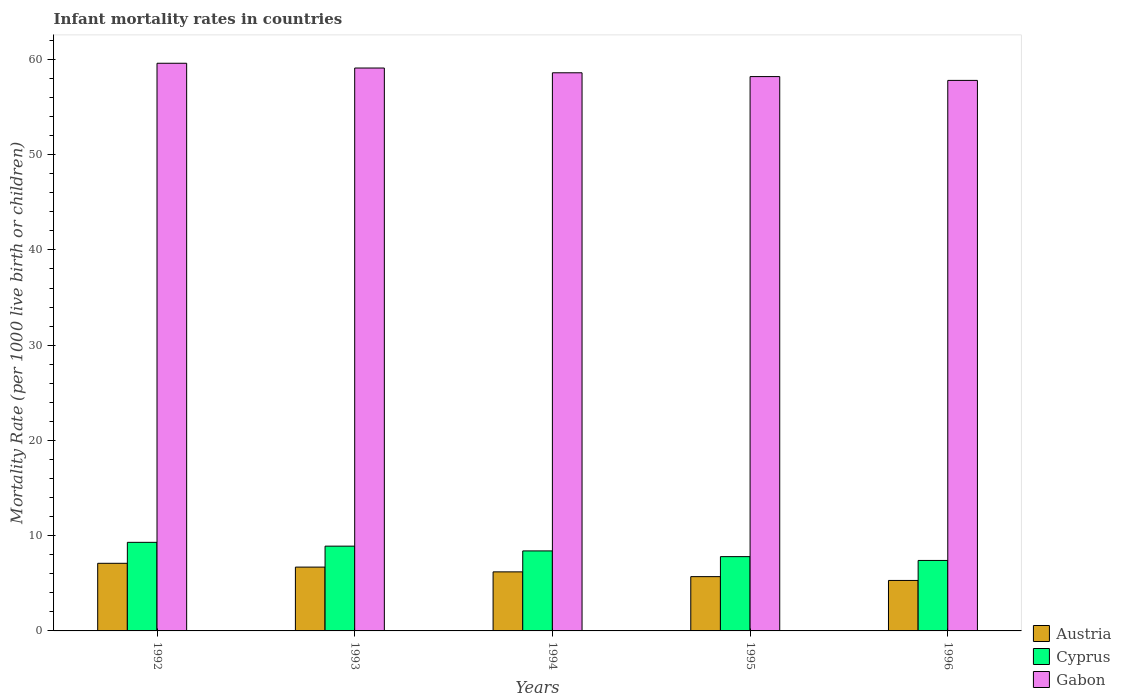How many different coloured bars are there?
Your answer should be very brief. 3. How many groups of bars are there?
Provide a succinct answer. 5. Are the number of bars per tick equal to the number of legend labels?
Give a very brief answer. Yes. Are the number of bars on each tick of the X-axis equal?
Ensure brevity in your answer.  Yes. How many bars are there on the 5th tick from the right?
Make the answer very short. 3. In how many cases, is the number of bars for a given year not equal to the number of legend labels?
Keep it short and to the point. 0. In which year was the infant mortality rate in Cyprus maximum?
Your answer should be very brief. 1992. In which year was the infant mortality rate in Cyprus minimum?
Provide a succinct answer. 1996. What is the total infant mortality rate in Gabon in the graph?
Keep it short and to the point. 293.3. What is the difference between the infant mortality rate in Cyprus in 1992 and that in 1995?
Make the answer very short. 1.5. What is the difference between the infant mortality rate in Cyprus in 1996 and the infant mortality rate in Austria in 1995?
Your answer should be very brief. 1.7. In the year 1992, what is the difference between the infant mortality rate in Gabon and infant mortality rate in Cyprus?
Keep it short and to the point. 50.3. What is the ratio of the infant mortality rate in Cyprus in 1993 to that in 1996?
Ensure brevity in your answer.  1.2. What is the difference between the highest and the second highest infant mortality rate in Cyprus?
Keep it short and to the point. 0.4. What is the difference between the highest and the lowest infant mortality rate in Cyprus?
Provide a succinct answer. 1.9. In how many years, is the infant mortality rate in Gabon greater than the average infant mortality rate in Gabon taken over all years?
Your answer should be compact. 2. What does the 3rd bar from the left in 1994 represents?
Make the answer very short. Gabon. How many bars are there?
Your response must be concise. 15. Are all the bars in the graph horizontal?
Your answer should be compact. No. What is the difference between two consecutive major ticks on the Y-axis?
Offer a very short reply. 10. How many legend labels are there?
Give a very brief answer. 3. What is the title of the graph?
Provide a short and direct response. Infant mortality rates in countries. What is the label or title of the Y-axis?
Offer a very short reply. Mortality Rate (per 1000 live birth or children). What is the Mortality Rate (per 1000 live birth or children) in Austria in 1992?
Provide a short and direct response. 7.1. What is the Mortality Rate (per 1000 live birth or children) of Gabon in 1992?
Provide a succinct answer. 59.6. What is the Mortality Rate (per 1000 live birth or children) in Austria in 1993?
Provide a succinct answer. 6.7. What is the Mortality Rate (per 1000 live birth or children) in Gabon in 1993?
Make the answer very short. 59.1. What is the Mortality Rate (per 1000 live birth or children) of Austria in 1994?
Make the answer very short. 6.2. What is the Mortality Rate (per 1000 live birth or children) of Cyprus in 1994?
Make the answer very short. 8.4. What is the Mortality Rate (per 1000 live birth or children) in Gabon in 1994?
Provide a succinct answer. 58.6. What is the Mortality Rate (per 1000 live birth or children) in Austria in 1995?
Offer a very short reply. 5.7. What is the Mortality Rate (per 1000 live birth or children) in Cyprus in 1995?
Your answer should be very brief. 7.8. What is the Mortality Rate (per 1000 live birth or children) in Gabon in 1995?
Make the answer very short. 58.2. What is the Mortality Rate (per 1000 live birth or children) of Cyprus in 1996?
Offer a terse response. 7.4. What is the Mortality Rate (per 1000 live birth or children) in Gabon in 1996?
Provide a succinct answer. 57.8. Across all years, what is the maximum Mortality Rate (per 1000 live birth or children) of Austria?
Give a very brief answer. 7.1. Across all years, what is the maximum Mortality Rate (per 1000 live birth or children) in Gabon?
Provide a succinct answer. 59.6. Across all years, what is the minimum Mortality Rate (per 1000 live birth or children) in Cyprus?
Provide a short and direct response. 7.4. Across all years, what is the minimum Mortality Rate (per 1000 live birth or children) in Gabon?
Provide a short and direct response. 57.8. What is the total Mortality Rate (per 1000 live birth or children) of Austria in the graph?
Ensure brevity in your answer.  31. What is the total Mortality Rate (per 1000 live birth or children) of Cyprus in the graph?
Your answer should be very brief. 41.8. What is the total Mortality Rate (per 1000 live birth or children) of Gabon in the graph?
Make the answer very short. 293.3. What is the difference between the Mortality Rate (per 1000 live birth or children) in Austria in 1992 and that in 1994?
Offer a very short reply. 0.9. What is the difference between the Mortality Rate (per 1000 live birth or children) of Cyprus in 1992 and that in 1995?
Make the answer very short. 1.5. What is the difference between the Mortality Rate (per 1000 live birth or children) in Gabon in 1992 and that in 1995?
Offer a terse response. 1.4. What is the difference between the Mortality Rate (per 1000 live birth or children) in Austria in 1992 and that in 1996?
Offer a terse response. 1.8. What is the difference between the Mortality Rate (per 1000 live birth or children) of Cyprus in 1992 and that in 1996?
Ensure brevity in your answer.  1.9. What is the difference between the Mortality Rate (per 1000 live birth or children) of Austria in 1993 and that in 1994?
Provide a short and direct response. 0.5. What is the difference between the Mortality Rate (per 1000 live birth or children) in Cyprus in 1993 and that in 1994?
Ensure brevity in your answer.  0.5. What is the difference between the Mortality Rate (per 1000 live birth or children) of Gabon in 1993 and that in 1995?
Your answer should be very brief. 0.9. What is the difference between the Mortality Rate (per 1000 live birth or children) in Austria in 1993 and that in 1996?
Provide a short and direct response. 1.4. What is the difference between the Mortality Rate (per 1000 live birth or children) in Gabon in 1993 and that in 1996?
Offer a very short reply. 1.3. What is the difference between the Mortality Rate (per 1000 live birth or children) in Austria in 1994 and that in 1995?
Your response must be concise. 0.5. What is the difference between the Mortality Rate (per 1000 live birth or children) in Cyprus in 1994 and that in 1996?
Provide a short and direct response. 1. What is the difference between the Mortality Rate (per 1000 live birth or children) in Gabon in 1994 and that in 1996?
Your response must be concise. 0.8. What is the difference between the Mortality Rate (per 1000 live birth or children) in Austria in 1995 and that in 1996?
Keep it short and to the point. 0.4. What is the difference between the Mortality Rate (per 1000 live birth or children) in Cyprus in 1995 and that in 1996?
Your answer should be very brief. 0.4. What is the difference between the Mortality Rate (per 1000 live birth or children) in Austria in 1992 and the Mortality Rate (per 1000 live birth or children) in Gabon in 1993?
Provide a short and direct response. -52. What is the difference between the Mortality Rate (per 1000 live birth or children) of Cyprus in 1992 and the Mortality Rate (per 1000 live birth or children) of Gabon in 1993?
Give a very brief answer. -49.8. What is the difference between the Mortality Rate (per 1000 live birth or children) of Austria in 1992 and the Mortality Rate (per 1000 live birth or children) of Gabon in 1994?
Offer a very short reply. -51.5. What is the difference between the Mortality Rate (per 1000 live birth or children) of Cyprus in 1992 and the Mortality Rate (per 1000 live birth or children) of Gabon in 1994?
Make the answer very short. -49.3. What is the difference between the Mortality Rate (per 1000 live birth or children) in Austria in 1992 and the Mortality Rate (per 1000 live birth or children) in Gabon in 1995?
Your response must be concise. -51.1. What is the difference between the Mortality Rate (per 1000 live birth or children) in Cyprus in 1992 and the Mortality Rate (per 1000 live birth or children) in Gabon in 1995?
Give a very brief answer. -48.9. What is the difference between the Mortality Rate (per 1000 live birth or children) of Austria in 1992 and the Mortality Rate (per 1000 live birth or children) of Cyprus in 1996?
Offer a terse response. -0.3. What is the difference between the Mortality Rate (per 1000 live birth or children) in Austria in 1992 and the Mortality Rate (per 1000 live birth or children) in Gabon in 1996?
Ensure brevity in your answer.  -50.7. What is the difference between the Mortality Rate (per 1000 live birth or children) in Cyprus in 1992 and the Mortality Rate (per 1000 live birth or children) in Gabon in 1996?
Your response must be concise. -48.5. What is the difference between the Mortality Rate (per 1000 live birth or children) in Austria in 1993 and the Mortality Rate (per 1000 live birth or children) in Gabon in 1994?
Your response must be concise. -51.9. What is the difference between the Mortality Rate (per 1000 live birth or children) of Cyprus in 1993 and the Mortality Rate (per 1000 live birth or children) of Gabon in 1994?
Ensure brevity in your answer.  -49.7. What is the difference between the Mortality Rate (per 1000 live birth or children) in Austria in 1993 and the Mortality Rate (per 1000 live birth or children) in Cyprus in 1995?
Your answer should be very brief. -1.1. What is the difference between the Mortality Rate (per 1000 live birth or children) of Austria in 1993 and the Mortality Rate (per 1000 live birth or children) of Gabon in 1995?
Keep it short and to the point. -51.5. What is the difference between the Mortality Rate (per 1000 live birth or children) of Cyprus in 1993 and the Mortality Rate (per 1000 live birth or children) of Gabon in 1995?
Provide a succinct answer. -49.3. What is the difference between the Mortality Rate (per 1000 live birth or children) in Austria in 1993 and the Mortality Rate (per 1000 live birth or children) in Cyprus in 1996?
Keep it short and to the point. -0.7. What is the difference between the Mortality Rate (per 1000 live birth or children) of Austria in 1993 and the Mortality Rate (per 1000 live birth or children) of Gabon in 1996?
Your response must be concise. -51.1. What is the difference between the Mortality Rate (per 1000 live birth or children) of Cyprus in 1993 and the Mortality Rate (per 1000 live birth or children) of Gabon in 1996?
Provide a succinct answer. -48.9. What is the difference between the Mortality Rate (per 1000 live birth or children) of Austria in 1994 and the Mortality Rate (per 1000 live birth or children) of Cyprus in 1995?
Your answer should be very brief. -1.6. What is the difference between the Mortality Rate (per 1000 live birth or children) of Austria in 1994 and the Mortality Rate (per 1000 live birth or children) of Gabon in 1995?
Offer a terse response. -52. What is the difference between the Mortality Rate (per 1000 live birth or children) in Cyprus in 1994 and the Mortality Rate (per 1000 live birth or children) in Gabon in 1995?
Make the answer very short. -49.8. What is the difference between the Mortality Rate (per 1000 live birth or children) of Austria in 1994 and the Mortality Rate (per 1000 live birth or children) of Gabon in 1996?
Keep it short and to the point. -51.6. What is the difference between the Mortality Rate (per 1000 live birth or children) in Cyprus in 1994 and the Mortality Rate (per 1000 live birth or children) in Gabon in 1996?
Your answer should be compact. -49.4. What is the difference between the Mortality Rate (per 1000 live birth or children) in Austria in 1995 and the Mortality Rate (per 1000 live birth or children) in Cyprus in 1996?
Your answer should be very brief. -1.7. What is the difference between the Mortality Rate (per 1000 live birth or children) in Austria in 1995 and the Mortality Rate (per 1000 live birth or children) in Gabon in 1996?
Give a very brief answer. -52.1. What is the average Mortality Rate (per 1000 live birth or children) of Austria per year?
Provide a short and direct response. 6.2. What is the average Mortality Rate (per 1000 live birth or children) of Cyprus per year?
Offer a terse response. 8.36. What is the average Mortality Rate (per 1000 live birth or children) in Gabon per year?
Your response must be concise. 58.66. In the year 1992, what is the difference between the Mortality Rate (per 1000 live birth or children) in Austria and Mortality Rate (per 1000 live birth or children) in Cyprus?
Offer a very short reply. -2.2. In the year 1992, what is the difference between the Mortality Rate (per 1000 live birth or children) of Austria and Mortality Rate (per 1000 live birth or children) of Gabon?
Your response must be concise. -52.5. In the year 1992, what is the difference between the Mortality Rate (per 1000 live birth or children) in Cyprus and Mortality Rate (per 1000 live birth or children) in Gabon?
Ensure brevity in your answer.  -50.3. In the year 1993, what is the difference between the Mortality Rate (per 1000 live birth or children) of Austria and Mortality Rate (per 1000 live birth or children) of Cyprus?
Provide a short and direct response. -2.2. In the year 1993, what is the difference between the Mortality Rate (per 1000 live birth or children) of Austria and Mortality Rate (per 1000 live birth or children) of Gabon?
Offer a terse response. -52.4. In the year 1993, what is the difference between the Mortality Rate (per 1000 live birth or children) in Cyprus and Mortality Rate (per 1000 live birth or children) in Gabon?
Offer a terse response. -50.2. In the year 1994, what is the difference between the Mortality Rate (per 1000 live birth or children) of Austria and Mortality Rate (per 1000 live birth or children) of Cyprus?
Keep it short and to the point. -2.2. In the year 1994, what is the difference between the Mortality Rate (per 1000 live birth or children) of Austria and Mortality Rate (per 1000 live birth or children) of Gabon?
Offer a very short reply. -52.4. In the year 1994, what is the difference between the Mortality Rate (per 1000 live birth or children) of Cyprus and Mortality Rate (per 1000 live birth or children) of Gabon?
Keep it short and to the point. -50.2. In the year 1995, what is the difference between the Mortality Rate (per 1000 live birth or children) of Austria and Mortality Rate (per 1000 live birth or children) of Cyprus?
Provide a succinct answer. -2.1. In the year 1995, what is the difference between the Mortality Rate (per 1000 live birth or children) of Austria and Mortality Rate (per 1000 live birth or children) of Gabon?
Offer a very short reply. -52.5. In the year 1995, what is the difference between the Mortality Rate (per 1000 live birth or children) of Cyprus and Mortality Rate (per 1000 live birth or children) of Gabon?
Your answer should be compact. -50.4. In the year 1996, what is the difference between the Mortality Rate (per 1000 live birth or children) in Austria and Mortality Rate (per 1000 live birth or children) in Gabon?
Make the answer very short. -52.5. In the year 1996, what is the difference between the Mortality Rate (per 1000 live birth or children) of Cyprus and Mortality Rate (per 1000 live birth or children) of Gabon?
Ensure brevity in your answer.  -50.4. What is the ratio of the Mortality Rate (per 1000 live birth or children) in Austria in 1992 to that in 1993?
Keep it short and to the point. 1.06. What is the ratio of the Mortality Rate (per 1000 live birth or children) of Cyprus in 1992 to that in 1993?
Your response must be concise. 1.04. What is the ratio of the Mortality Rate (per 1000 live birth or children) in Gabon in 1992 to that in 1993?
Your response must be concise. 1.01. What is the ratio of the Mortality Rate (per 1000 live birth or children) of Austria in 1992 to that in 1994?
Provide a short and direct response. 1.15. What is the ratio of the Mortality Rate (per 1000 live birth or children) in Cyprus in 1992 to that in 1994?
Your response must be concise. 1.11. What is the ratio of the Mortality Rate (per 1000 live birth or children) in Gabon in 1992 to that in 1994?
Make the answer very short. 1.02. What is the ratio of the Mortality Rate (per 1000 live birth or children) of Austria in 1992 to that in 1995?
Make the answer very short. 1.25. What is the ratio of the Mortality Rate (per 1000 live birth or children) in Cyprus in 1992 to that in 1995?
Provide a short and direct response. 1.19. What is the ratio of the Mortality Rate (per 1000 live birth or children) in Gabon in 1992 to that in 1995?
Your answer should be compact. 1.02. What is the ratio of the Mortality Rate (per 1000 live birth or children) in Austria in 1992 to that in 1996?
Make the answer very short. 1.34. What is the ratio of the Mortality Rate (per 1000 live birth or children) of Cyprus in 1992 to that in 1996?
Your answer should be very brief. 1.26. What is the ratio of the Mortality Rate (per 1000 live birth or children) in Gabon in 1992 to that in 1996?
Offer a terse response. 1.03. What is the ratio of the Mortality Rate (per 1000 live birth or children) of Austria in 1993 to that in 1994?
Keep it short and to the point. 1.08. What is the ratio of the Mortality Rate (per 1000 live birth or children) of Cyprus in 1993 to that in 1994?
Give a very brief answer. 1.06. What is the ratio of the Mortality Rate (per 1000 live birth or children) in Gabon in 1993 to that in 1994?
Give a very brief answer. 1.01. What is the ratio of the Mortality Rate (per 1000 live birth or children) of Austria in 1993 to that in 1995?
Offer a terse response. 1.18. What is the ratio of the Mortality Rate (per 1000 live birth or children) in Cyprus in 1993 to that in 1995?
Your answer should be very brief. 1.14. What is the ratio of the Mortality Rate (per 1000 live birth or children) in Gabon in 1993 to that in 1995?
Offer a terse response. 1.02. What is the ratio of the Mortality Rate (per 1000 live birth or children) in Austria in 1993 to that in 1996?
Provide a succinct answer. 1.26. What is the ratio of the Mortality Rate (per 1000 live birth or children) in Cyprus in 1993 to that in 1996?
Your answer should be very brief. 1.2. What is the ratio of the Mortality Rate (per 1000 live birth or children) of Gabon in 1993 to that in 1996?
Your answer should be very brief. 1.02. What is the ratio of the Mortality Rate (per 1000 live birth or children) in Austria in 1994 to that in 1995?
Provide a succinct answer. 1.09. What is the ratio of the Mortality Rate (per 1000 live birth or children) of Austria in 1994 to that in 1996?
Keep it short and to the point. 1.17. What is the ratio of the Mortality Rate (per 1000 live birth or children) of Cyprus in 1994 to that in 1996?
Provide a short and direct response. 1.14. What is the ratio of the Mortality Rate (per 1000 live birth or children) of Gabon in 1994 to that in 1996?
Ensure brevity in your answer.  1.01. What is the ratio of the Mortality Rate (per 1000 live birth or children) of Austria in 1995 to that in 1996?
Provide a short and direct response. 1.08. What is the ratio of the Mortality Rate (per 1000 live birth or children) in Cyprus in 1995 to that in 1996?
Ensure brevity in your answer.  1.05. What is the ratio of the Mortality Rate (per 1000 live birth or children) of Gabon in 1995 to that in 1996?
Ensure brevity in your answer.  1.01. What is the difference between the highest and the second highest Mortality Rate (per 1000 live birth or children) in Cyprus?
Make the answer very short. 0.4. What is the difference between the highest and the second highest Mortality Rate (per 1000 live birth or children) of Gabon?
Your answer should be compact. 0.5. What is the difference between the highest and the lowest Mortality Rate (per 1000 live birth or children) in Austria?
Your answer should be compact. 1.8. What is the difference between the highest and the lowest Mortality Rate (per 1000 live birth or children) in Cyprus?
Offer a terse response. 1.9. 